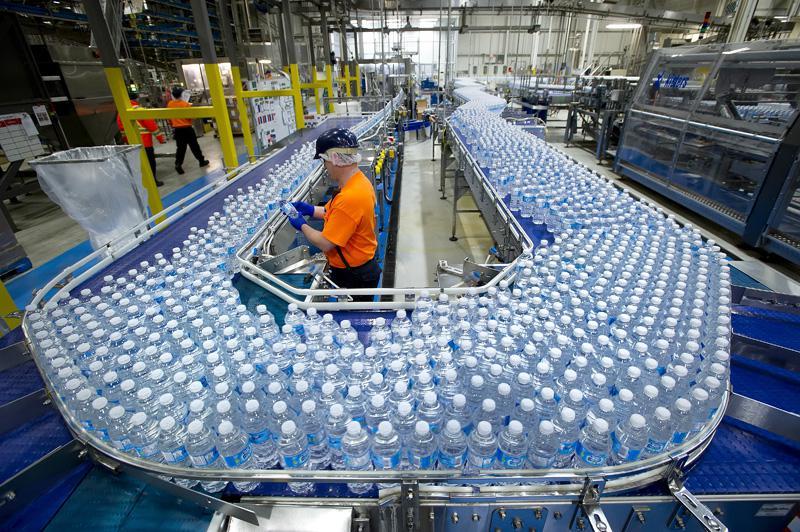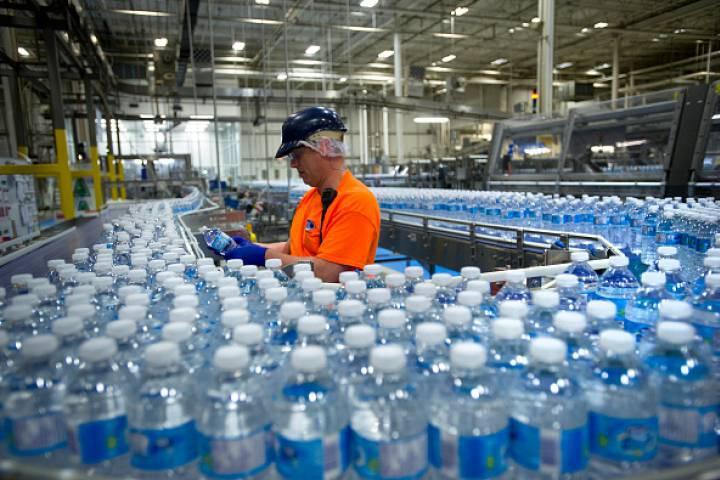The first image is the image on the left, the second image is the image on the right. Assess this claim about the two images: "A person in an orange shirt stands near a belt of bottles.". Correct or not? Answer yes or no. Yes. 